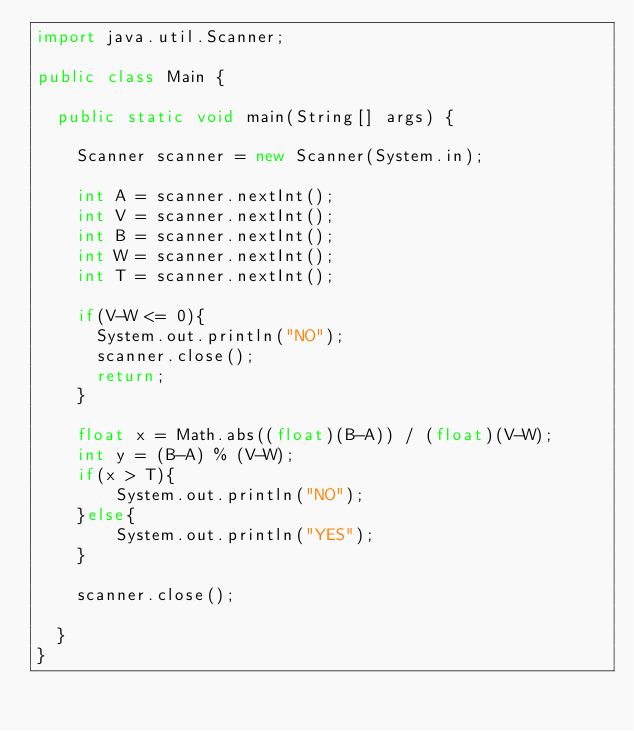<code> <loc_0><loc_0><loc_500><loc_500><_Java_>import java.util.Scanner;

public class Main {

  public static void main(String[] args) {

    Scanner scanner = new Scanner(System.in);

    int A = scanner.nextInt();
    int V = scanner.nextInt();
    int B = scanner.nextInt();
    int W = scanner.nextInt();
    int T = scanner.nextInt();

    if(V-W <= 0){
      System.out.println("NO");
      scanner.close();
      return;
    }

    float x = Math.abs((float)(B-A)) / (float)(V-W);
    int y = (B-A) % (V-W);
    if(x > T){
        System.out.println("NO");
    }else{
        System.out.println("YES");
    }

    scanner.close();

  }
}</code> 